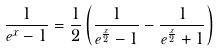Convert formula to latex. <formula><loc_0><loc_0><loc_500><loc_500>\frac { 1 } { e ^ { x } - 1 } = \frac { 1 } { 2 } \left ( \frac { 1 } { e ^ { \frac { x } { 2 } } - 1 } - \frac { 1 } { e ^ { \frac { x } { 2 } } + 1 } \right )</formula> 